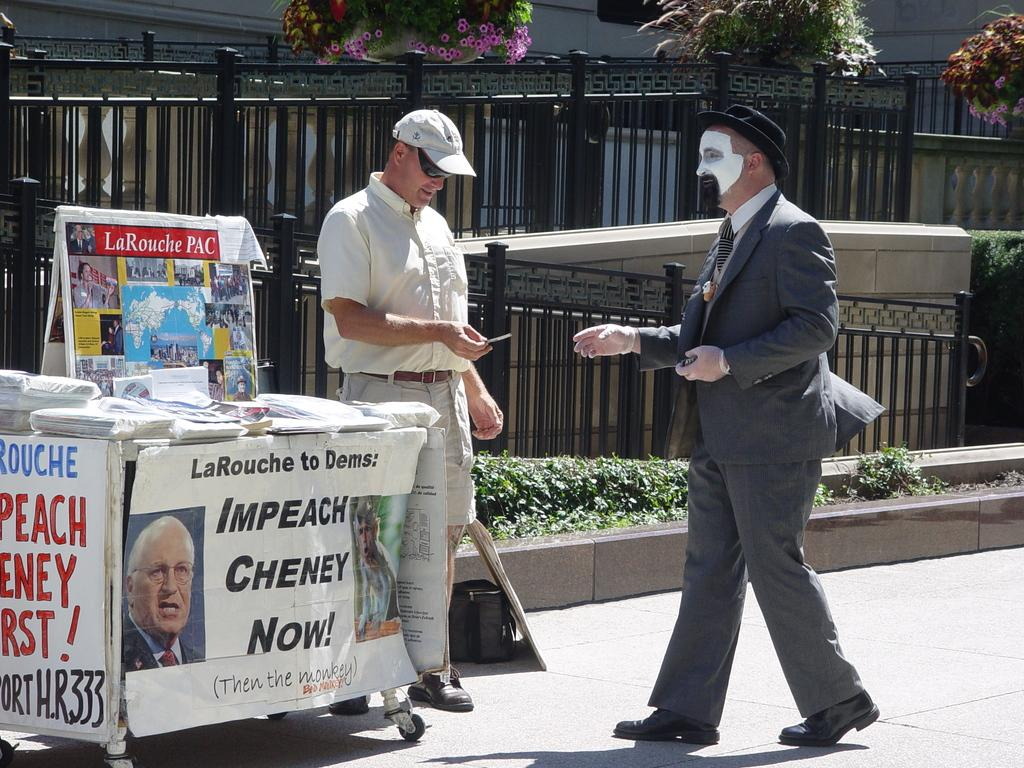How many people are standing on the road in the image? There are two persons standing on the road in the image. What is located beside the persons? There is a road beside the persons. What is behind the persons? There is a railing behind the persons. What type of vegetation is visible behind the railing? There are plants behind the railing. What date is marked on the calendar hanging on the roof in the image? There is no calendar or roof present in the image. 